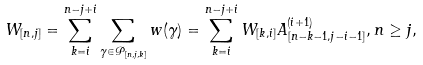Convert formula to latex. <formula><loc_0><loc_0><loc_500><loc_500>W _ { [ n , j ] } = \sum _ { k = i } ^ { n - j + i } \sum _ { \gamma \in \mathcal { P } _ { [ n , j , k ] } } w ( \gamma ) = \sum _ { k = i } ^ { n - j + i } W _ { [ k , i ] } A _ { [ n - k - 1 , j - i - 1 ] } ^ { ( i + 1 ) } , n \geq j ,</formula> 